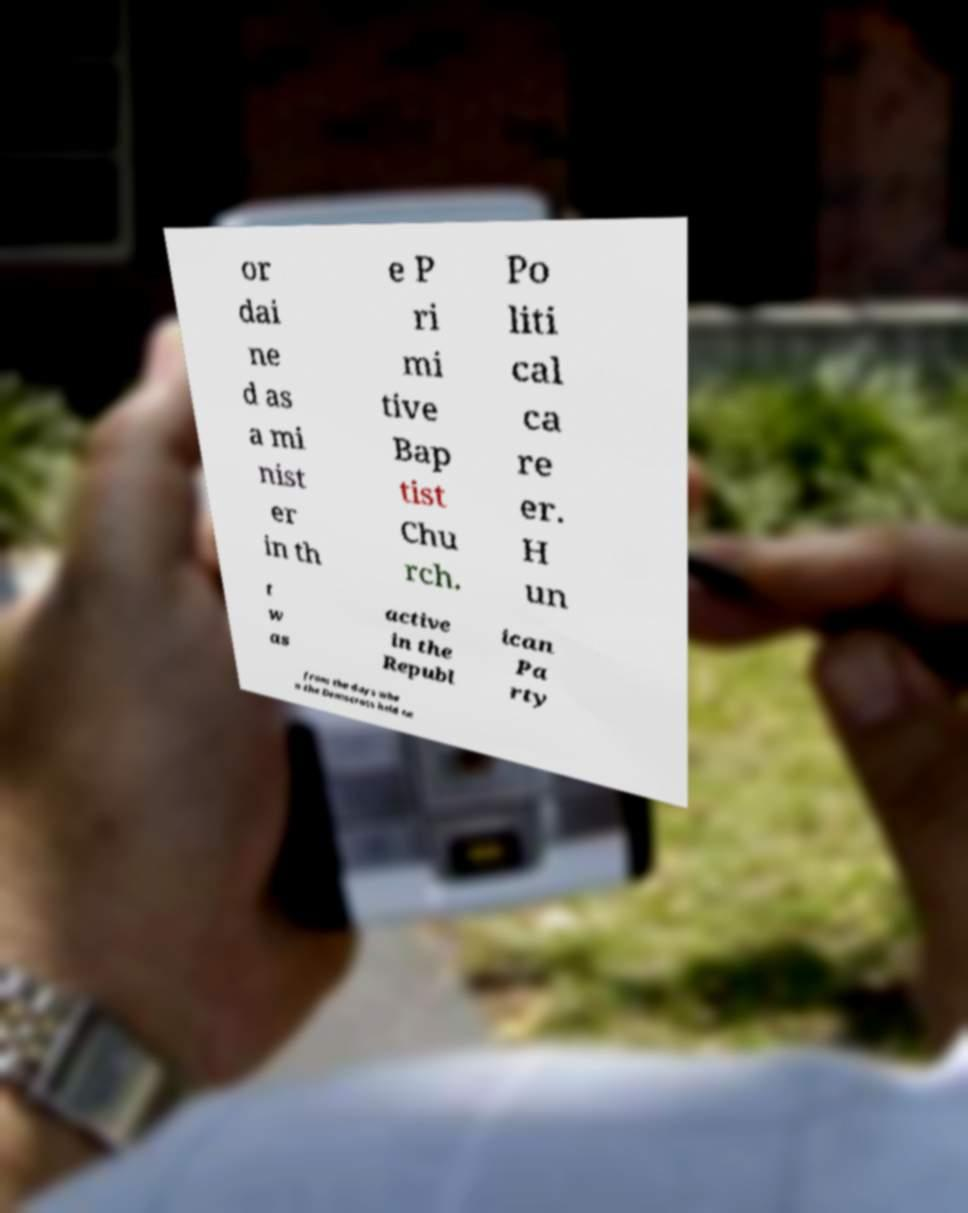There's text embedded in this image that I need extracted. Can you transcribe it verbatim? or dai ne d as a mi nist er in th e P ri mi tive Bap tist Chu rch. Po liti cal ca re er. H un t w as active in the Republ ican Pa rty from the days whe n the Democrats held ne 